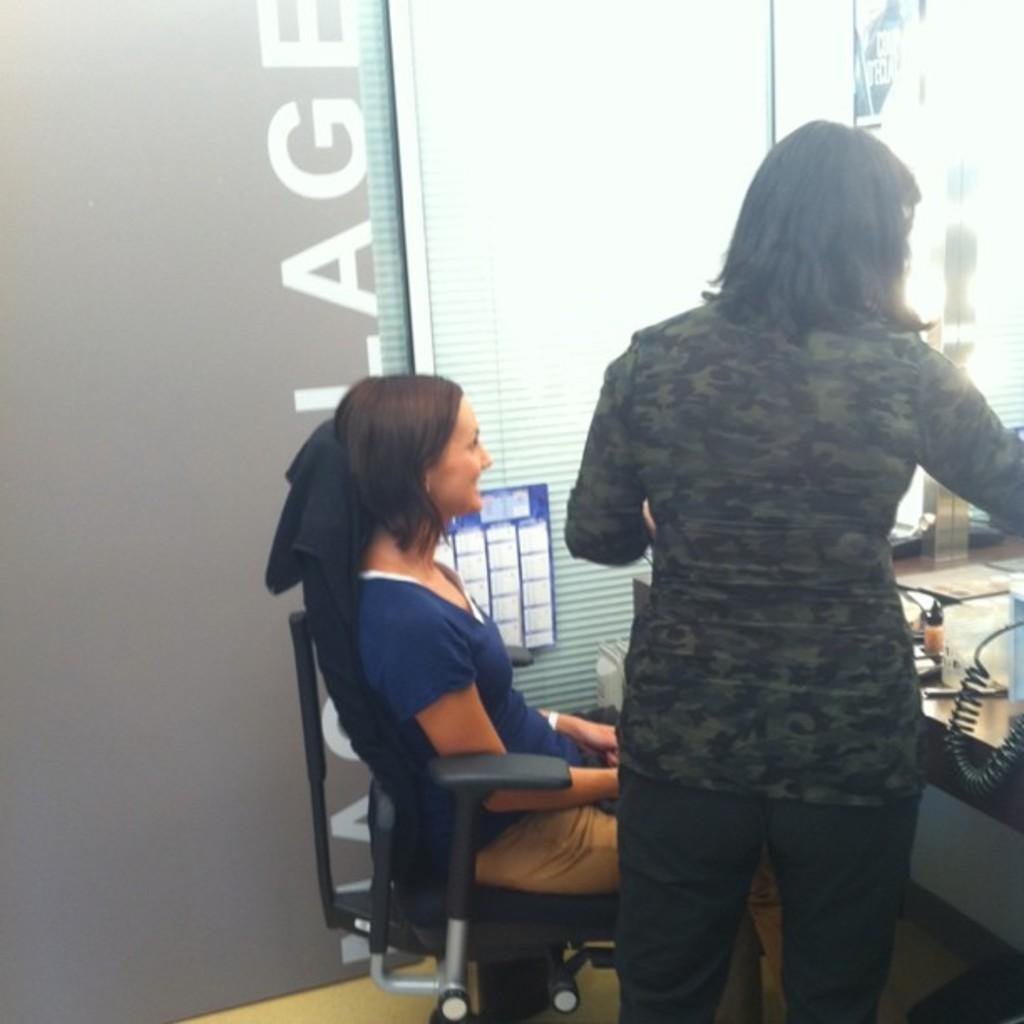Who is present in the image? There is a woman in the image. What is the woman doing in the image? The woman is sitting in a chair. What type of wall can be seen in the image? There is a glass wall in the image. What type of beetle can be seen crawling on the glass wall in the image? There is no beetle present in the image; it only features a woman sitting in a chair and a glass wall. 